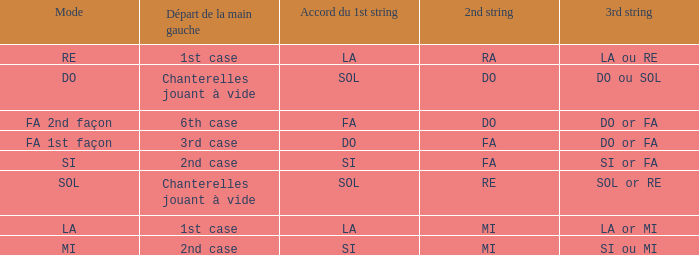For a 1st string of si Accord du and a 2nd string of mi what is the 3rd string? SI ou MI. 